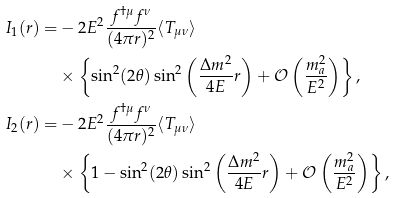<formula> <loc_0><loc_0><loc_500><loc_500>I _ { 1 } ( r ) = & - 2 E ^ { 2 } \frac { f ^ { \dag \mu } f ^ { \nu } } { ( 4 \pi r ) ^ { 2 } } \langle T _ { \mu \nu } \rangle \\ & \times \left \{ \sin ^ { 2 } ( 2 \theta ) \sin ^ { 2 } \left ( \frac { \Delta m ^ { 2 } } { 4 E } r \right ) + \mathcal { O } \left ( \frac { m _ { a } ^ { 2 } } { E ^ { 2 } } \right ) \right \} , \\ I _ { 2 } ( r ) = & - 2 E ^ { 2 } \frac { f ^ { \dag \mu } f ^ { \nu } } { ( 4 \pi r ) ^ { 2 } } \langle T _ { \mu \nu } \rangle \\ & \times \left \{ 1 - \sin ^ { 2 } ( 2 \theta ) \sin ^ { 2 } \left ( \frac { \Delta m ^ { 2 } } { 4 E } r \right ) + \mathcal { O } \left ( \frac { m _ { a } ^ { 2 } } { E ^ { 2 } } \right ) \right \} ,</formula> 